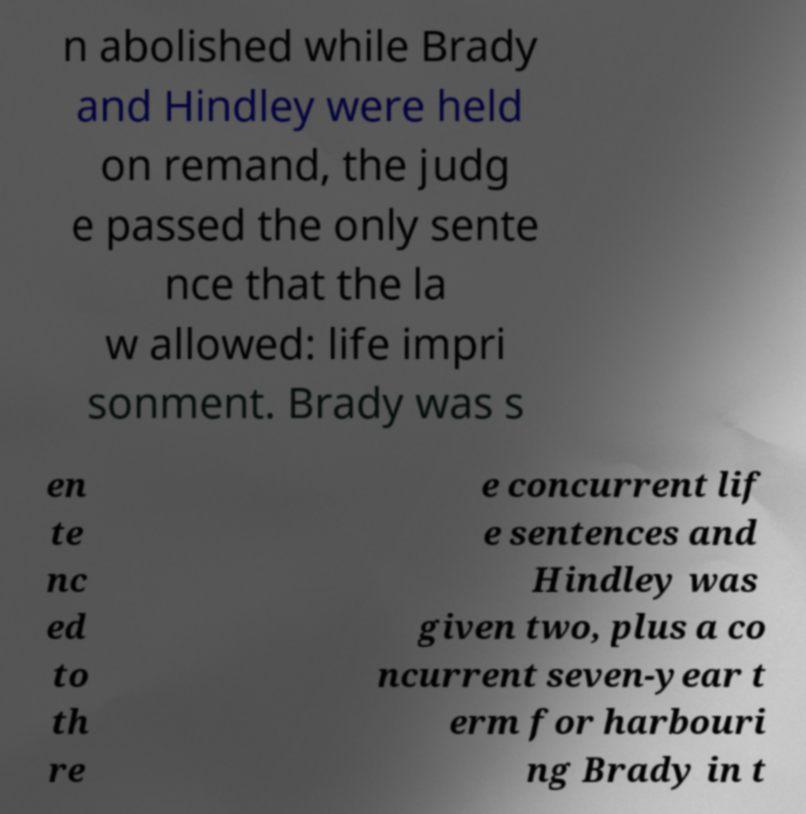Could you extract and type out the text from this image? n abolished while Brady and Hindley were held on remand, the judg e passed the only sente nce that the la w allowed: life impri sonment. Brady was s en te nc ed to th re e concurrent lif e sentences and Hindley was given two, plus a co ncurrent seven-year t erm for harbouri ng Brady in t 